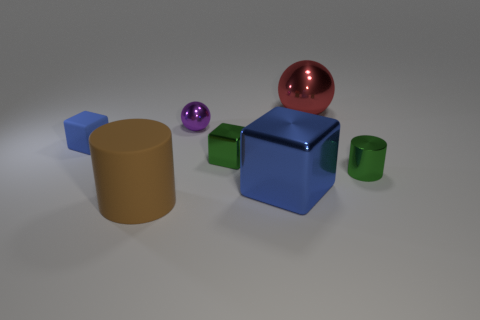Are there any small metallic spheres that have the same color as the large cylinder?
Keep it short and to the point. No. There is a cylinder that is the same size as the blue matte object; what color is it?
Offer a very short reply. Green. What number of big things are either spheres or objects?
Ensure brevity in your answer.  3. Are there the same number of big red objects that are in front of the red metal thing and green metal cylinders in front of the blue metallic thing?
Keep it short and to the point. Yes. What number of blue metal objects are the same size as the brown rubber object?
Offer a terse response. 1. What number of brown things are either big metallic things or big matte things?
Keep it short and to the point. 1. Is the number of small purple metallic balls that are to the right of the purple shiny thing the same as the number of large blue metallic objects?
Offer a very short reply. No. There is a shiny ball that is right of the purple metal thing; what size is it?
Your answer should be very brief. Large. How many green metallic things are the same shape as the blue rubber object?
Your answer should be very brief. 1. What is the big object that is both in front of the purple metallic sphere and right of the rubber cylinder made of?
Give a very brief answer. Metal. 